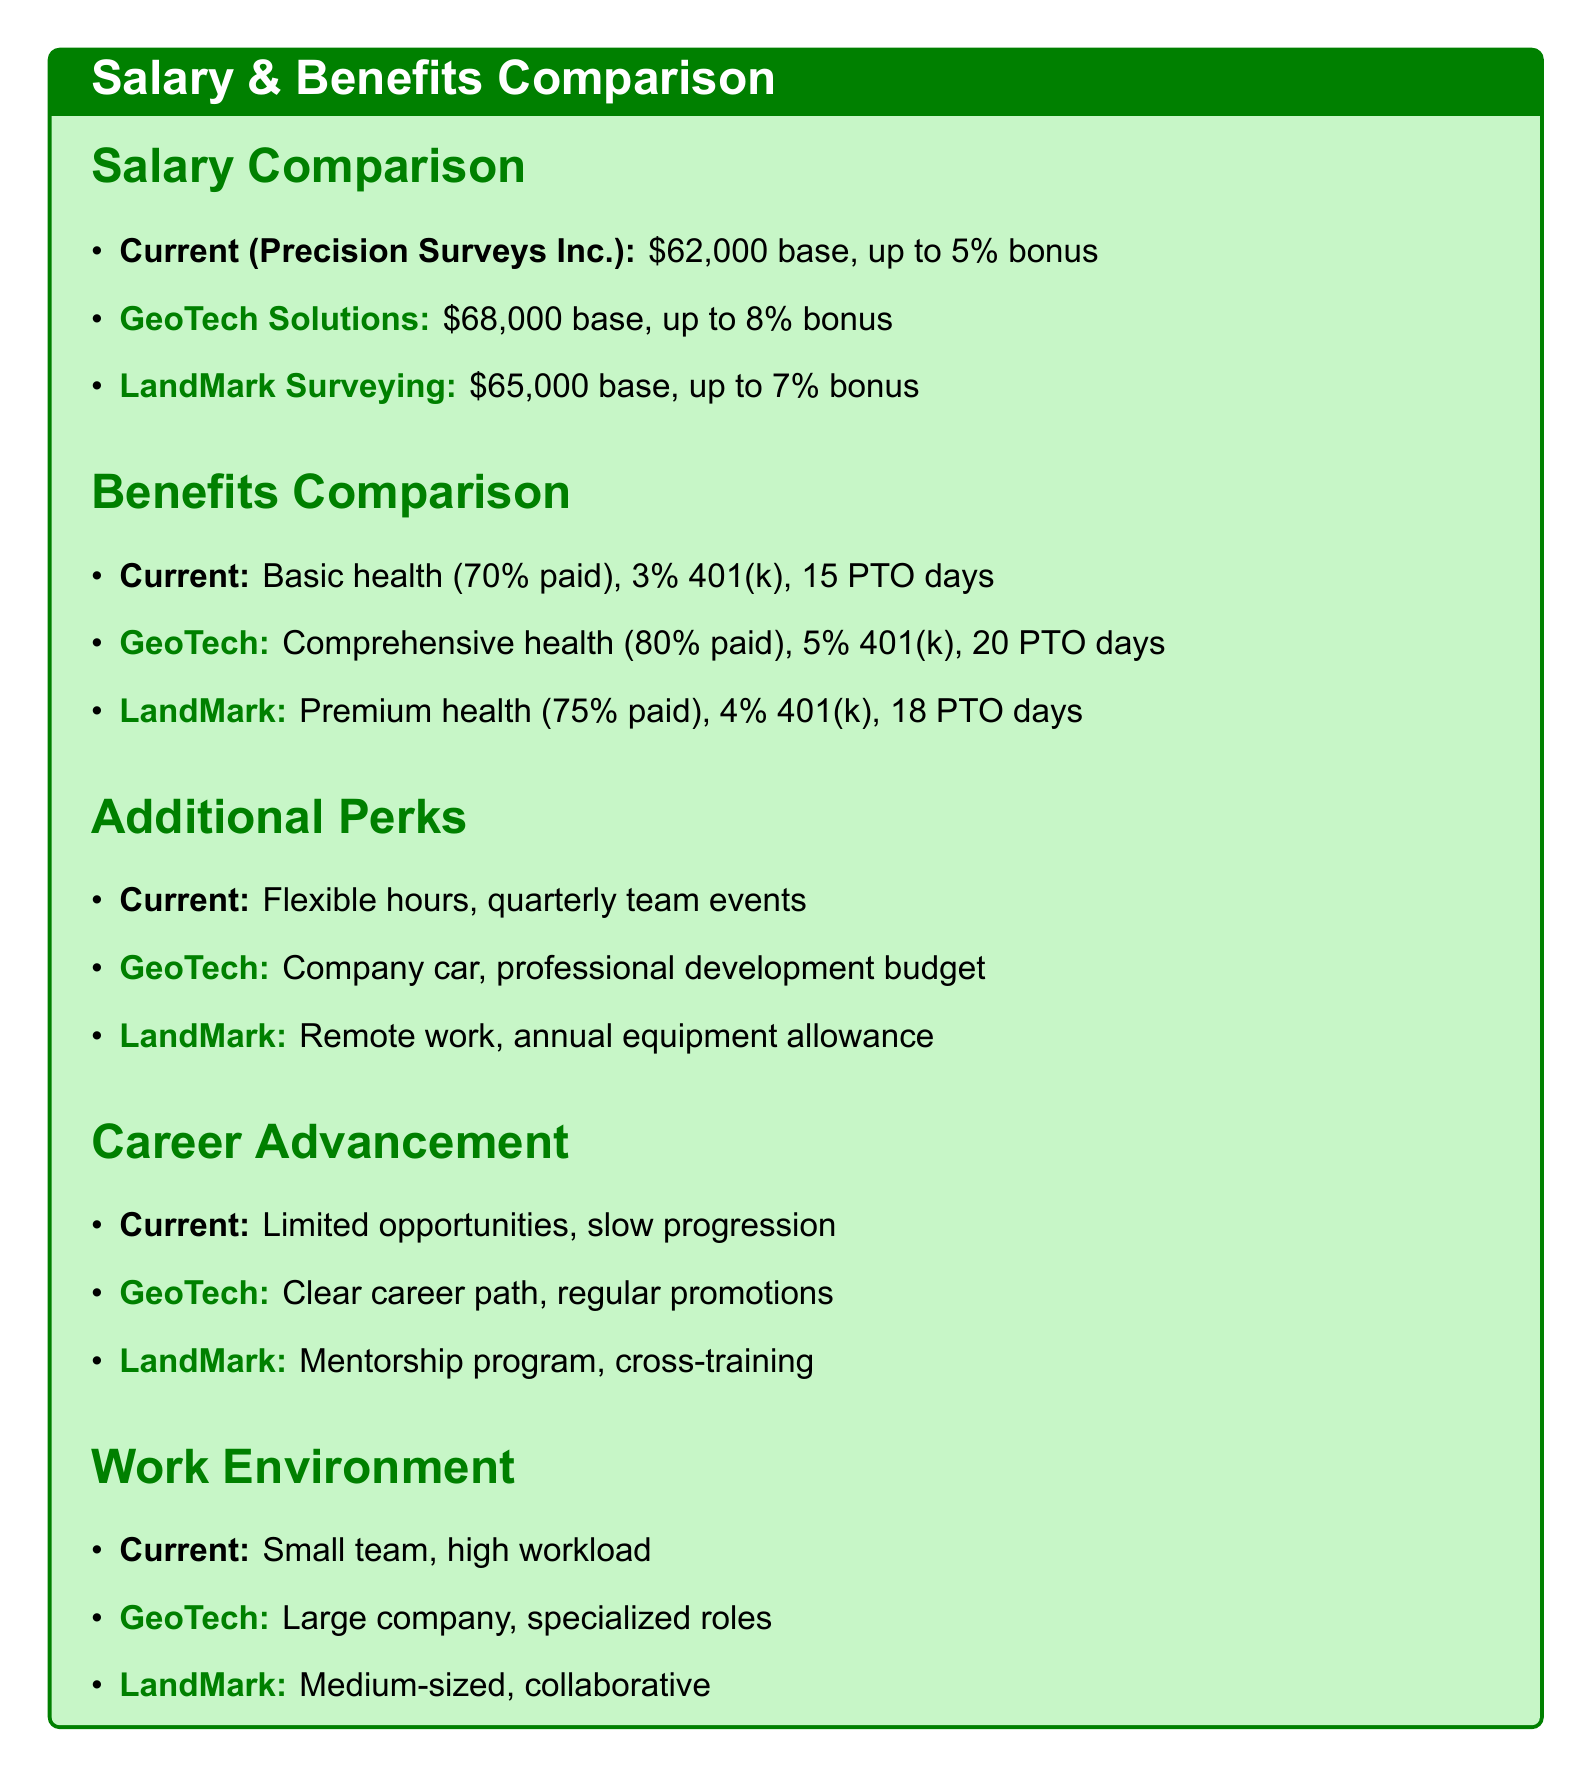What is the base salary at GeoTech Solutions? The base salary at GeoTech Solutions is directly mentioned in the document as $68,000.
Answer: $68,000 How many paid time off days does LandMark Surveying offer? The document states that LandMark Surveying offers 18 days of paid time off.
Answer: 18 days What is the retirement plan match at Precision Surveys Inc.? The document specifies that Precision Surveys Inc. offers a 3% 401(k) match as part of their retirement plan.
Answer: 3% Which competitor offers a professional development budget? The document indicates that GeoTech Solutions provides a professional development budget as an additional perk.
Answer: GeoTech Solutions What is the work environment like at LandMark Surveying? The document describes LandMark Surveying's work environment as medium-sized with a collaborative atmosphere.
Answer: Medium-sized, collaborative Which company has limited career advancement opportunities? The document clearly states that Precision Surveys Inc. has limited career advancement opportunities.
Answer: Precision Surveys Inc What percentage of the health insurance is employer-paid at GeoTech Solutions? The document mentions that GeoTech Solutions has 80% of health insurance employer-paid.
Answer: 80% How does the annual bonus at Precision Surveys Inc. compare to competitors? The annual bonus at Precision Surveys Inc. is lower than both competitors (5% compared to 8% and 7%).
Answer: Lower What additional perk does LandMark Surveying offer? The document lists remote work options and an annual surveying equipment allowance as additional perks for LandMark Surveying.
Answer: Remote work options, annual surveying equipment allowance 